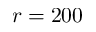Convert formula to latex. <formula><loc_0><loc_0><loc_500><loc_500>r = 2 0 0</formula> 